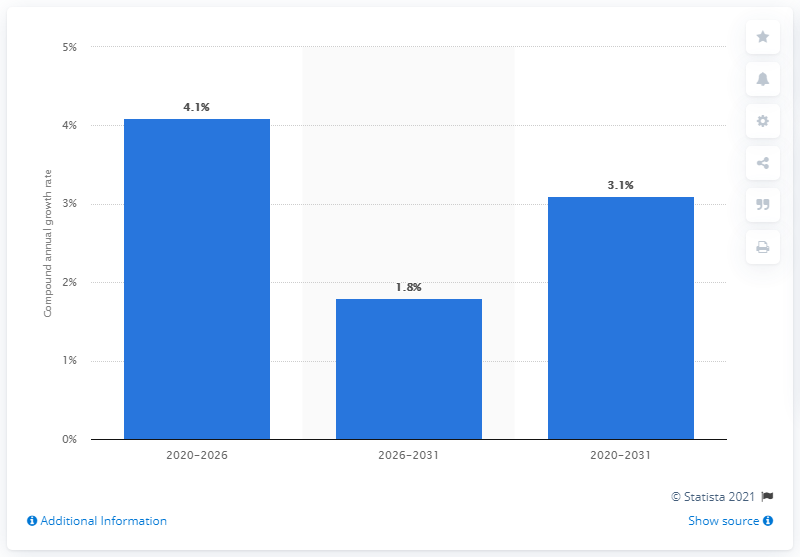Draw attention to some important aspects in this diagram. The aircraft maintenance, repair, and overhaul (MRO) market in the Middle East region is projected to experience a growth rate of 4.1% from 2020 to 2026. 